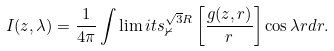<formula> <loc_0><loc_0><loc_500><loc_500>I ( z , \lambda ) = \frac { 1 } { 4 \pi } \int \lim i t s _ { \mathbb { 0 } } ^ { \sqrt { 3 } R } \left [ \frac { g ( z , r ) } { r } \right ] \cos \lambda r d r .</formula> 